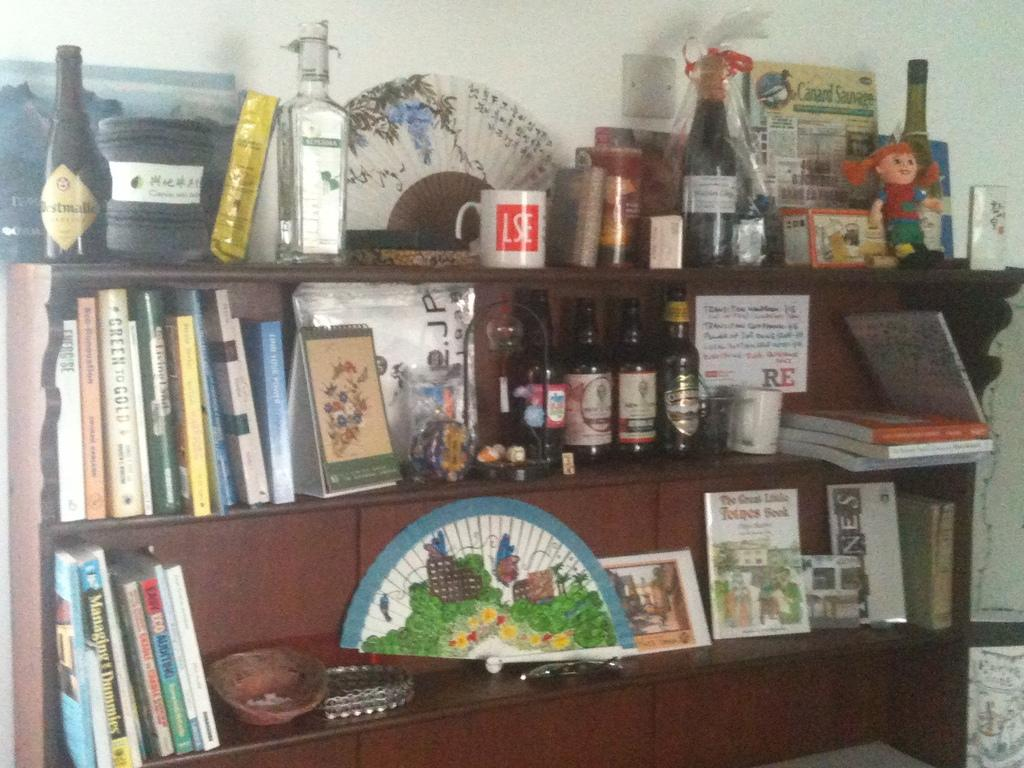What is the main object in the image? There is a stand in the image. What items can be seen on the stand? There are books, bottles, a cup, and decorations on the stand. What is visible in the background of the image? There is a wall in the background of the image. What type of eggnog is being served in the cup on the stand? There is no eggnog present in the image; it is a cup, not a container for eggnog. Can you tell me how many sisters are depicted in the image? There are no people, let alone sisters, depicted in the image; it features a stand with various items on it. 